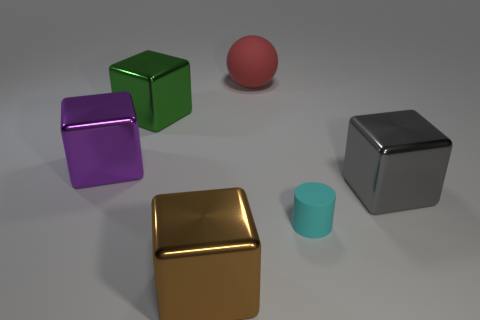Could there be a functional purpose for these objects, or are they purely decorative? Based on the image alone, it's challenging to determine a functional purpose. They could be models used for educational purposes, such as teaching geometry, or they might be elements of a decorative arrangement, created to be aesthetically pleasing. 